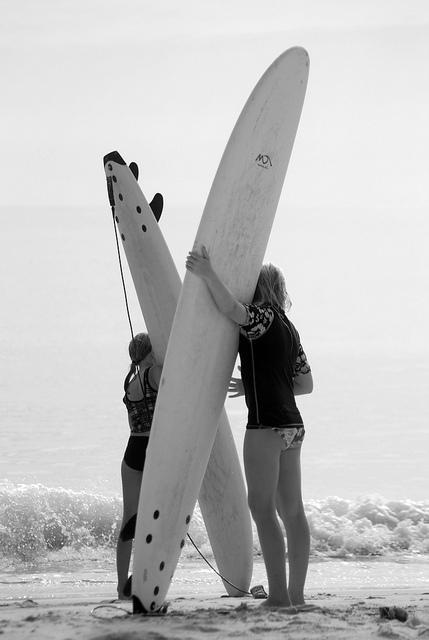How many surfboards can be seen?
Give a very brief answer. 2. How many people can be seen?
Give a very brief answer. 2. How many people running with a kite on the sand?
Give a very brief answer. 0. 